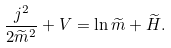<formula> <loc_0><loc_0><loc_500><loc_500>\frac { j ^ { 2 } } { 2 \widetilde { m } ^ { 2 } } + V = \ln \widetilde { m } + \widetilde { H } .</formula> 